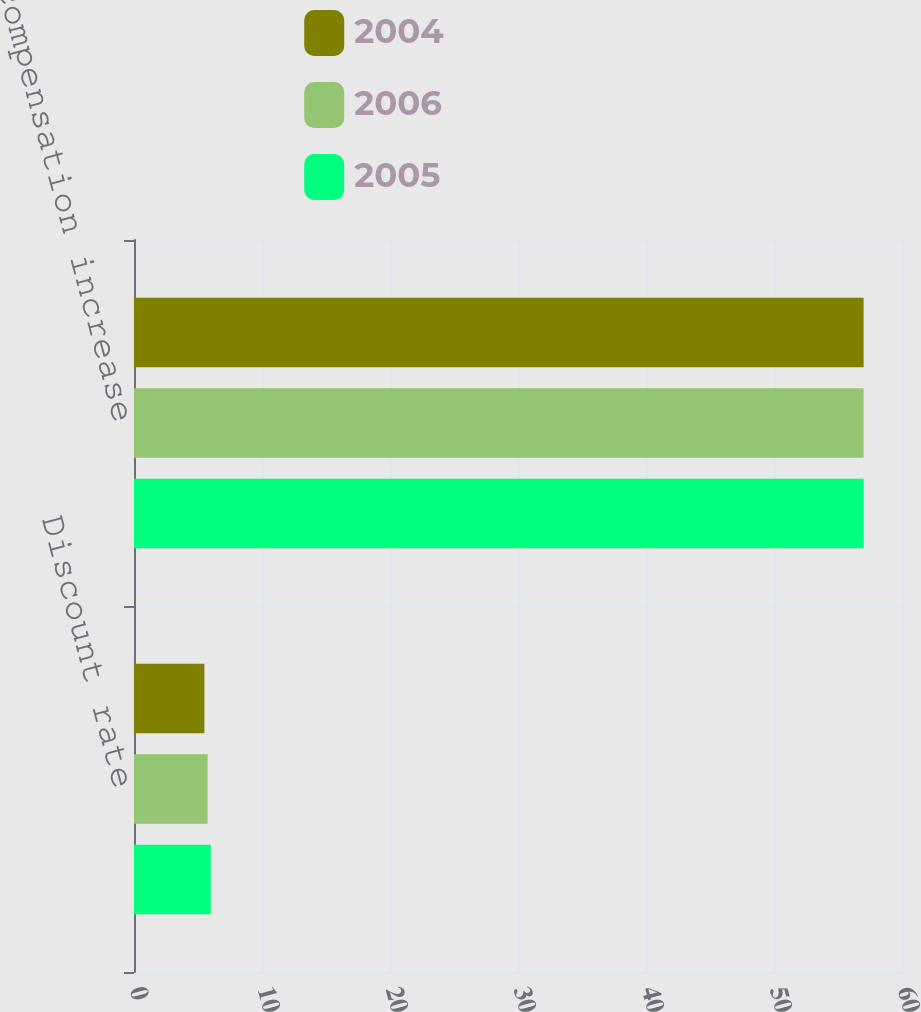Convert chart to OTSL. <chart><loc_0><loc_0><loc_500><loc_500><stacked_bar_chart><ecel><fcel>Discount rate<fcel>Rate of compensation increase<nl><fcel>2004<fcel>5.5<fcel>57<nl><fcel>2006<fcel>5.75<fcel>57<nl><fcel>2005<fcel>6<fcel>57<nl></chart> 